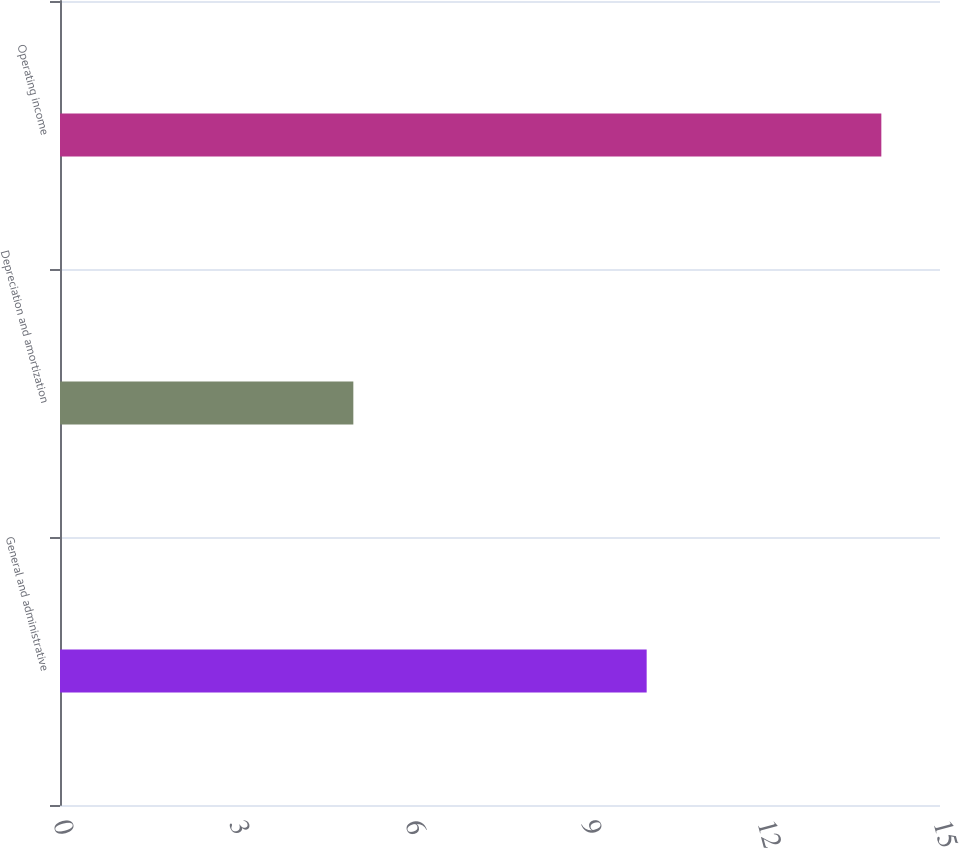<chart> <loc_0><loc_0><loc_500><loc_500><bar_chart><fcel>General and administrative<fcel>Depreciation and amortization<fcel>Operating income<nl><fcel>10<fcel>5<fcel>14<nl></chart> 